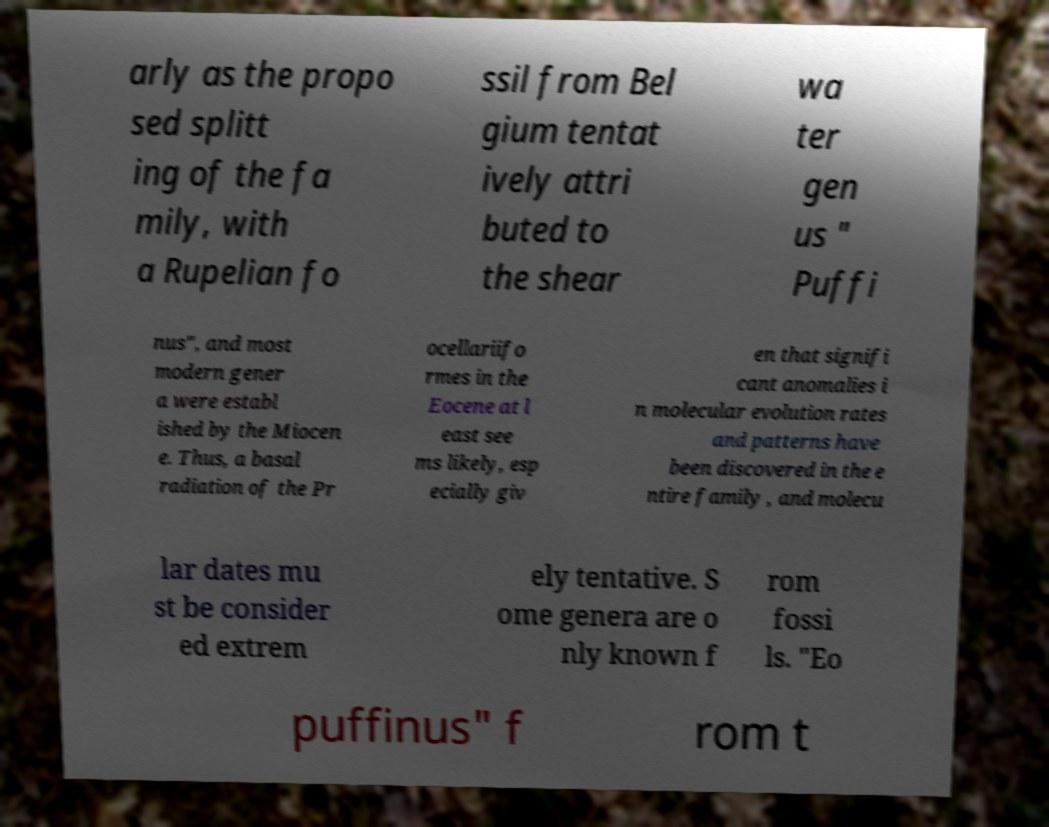Could you extract and type out the text from this image? arly as the propo sed splitt ing of the fa mily, with a Rupelian fo ssil from Bel gium tentat ively attri buted to the shear wa ter gen us " Puffi nus", and most modern gener a were establ ished by the Miocen e. Thus, a basal radiation of the Pr ocellariifo rmes in the Eocene at l east see ms likely, esp ecially giv en that signifi cant anomalies i n molecular evolution rates and patterns have been discovered in the e ntire family , and molecu lar dates mu st be consider ed extrem ely tentative. S ome genera are o nly known f rom fossi ls. "Eo puffinus" f rom t 